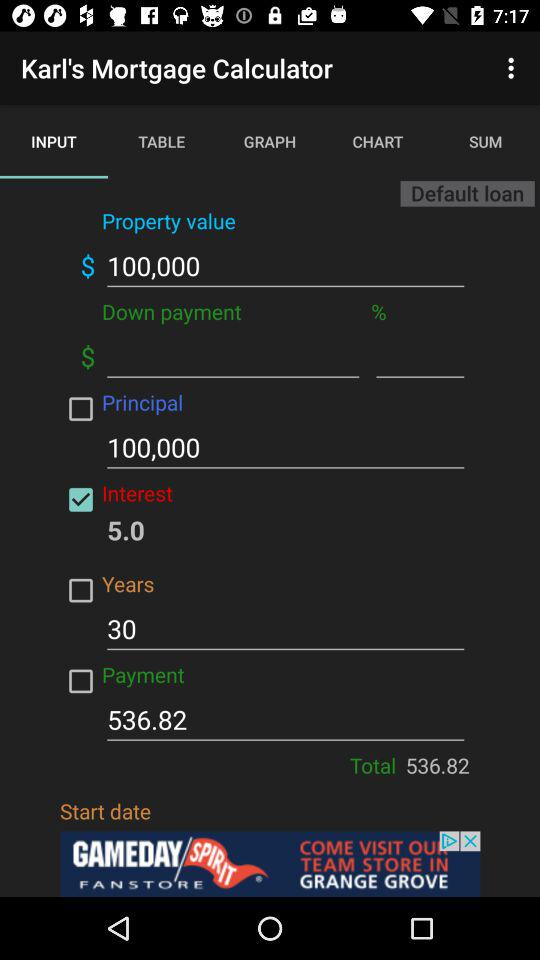How long is the interest rate calculated? The interest rate is calculated for 30 years. 